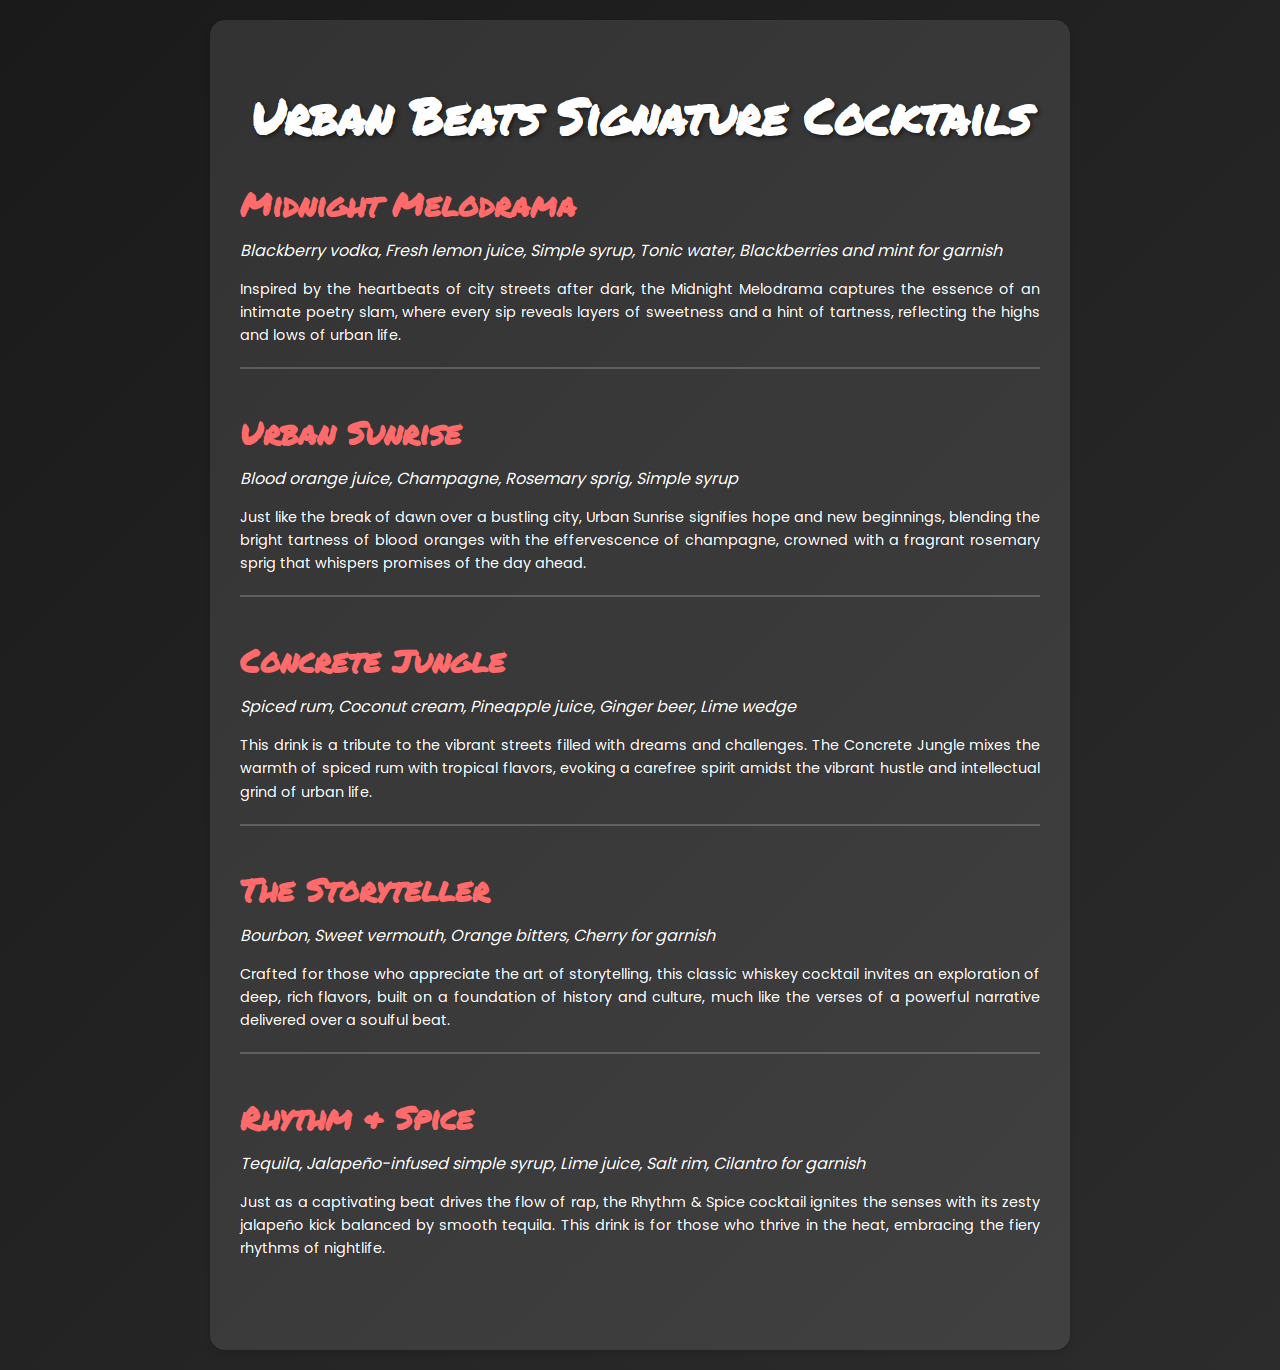what is the name of the first cocktail? The first cocktail listed in the menu is Midnight Melodrama.
Answer: Midnight Melodrama how many ingredients are in the Urban Sunrise cocktail? The ingredients listed for Urban Sunrise are blood orange juice, champagne, rosemary sprig, and simple syrup, totaling four ingredients.
Answer: 4 which cocktail contains ginger beer? Concrete Jungle is the cocktail that includes ginger beer as one of its ingredients.
Answer: Concrete Jungle what flavor is highlighted in the Rhythm & Spice cocktail? The Rhythm & Spice cocktail is characterized by a jalapeño kick, which adds a spicy flavor.
Answer: jalapeño which cocktail is dedicated to storytelling? The cocktail crafted for storytelling is named The Storyteller.
Answer: The Storyteller what garnish is used in the Midnight Melodrama? The garnish used in the Midnight Melodrama includes blackberries and mint.
Answer: blackberries and mint how does Urban Sunrise symbolize new beginnings? Urban Sunrise symbolizes new beginnings through its bright tartness and effervescence, reflecting hope as the dawn breaks over the city.
Answer: hope and new beginnings which drink evokes tropical flavors? The Concrete Jungle cocktail evokes tropical flavors through its combination of pineapple juice and coconut cream.
Answer: Concrete Jungle 